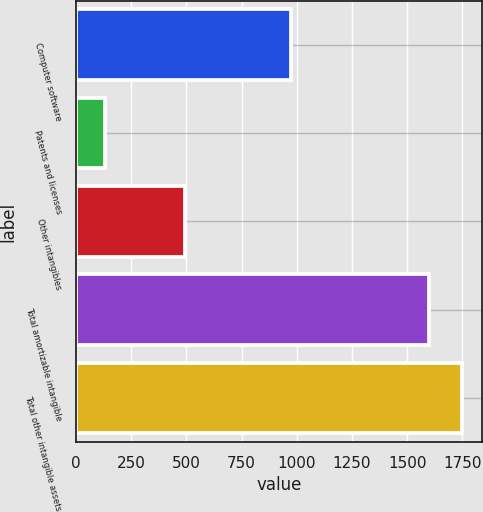<chart> <loc_0><loc_0><loc_500><loc_500><bar_chart><fcel>Computer software<fcel>Patents and licenses<fcel>Other intangibles<fcel>Total amortizable intangible<fcel>Total other intangible assets<nl><fcel>973<fcel>133<fcel>493<fcel>1599<fcel>1750.2<nl></chart> 